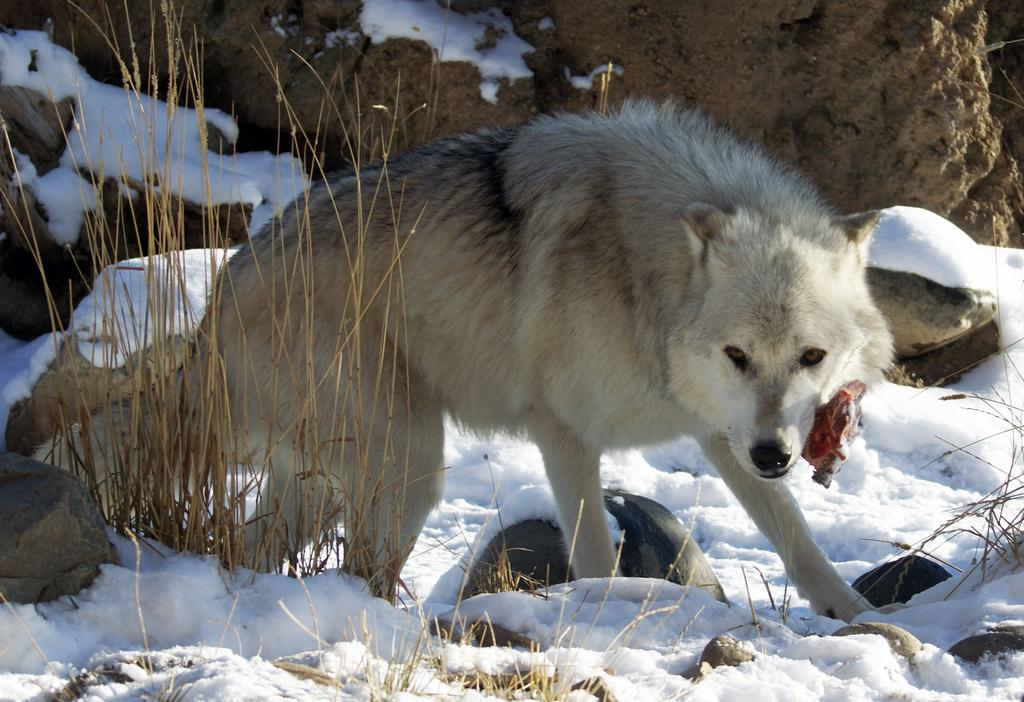What animal can be seen in the image? There is a fox in the image. What is the fox standing on? The fox is on the snow. What type of vegetation is visible on the left side of the image? There is grass visible on the left side of the image. What color is the sky in the image? There is no mention of the sky in the provided facts, so it cannot be determined from the image. 